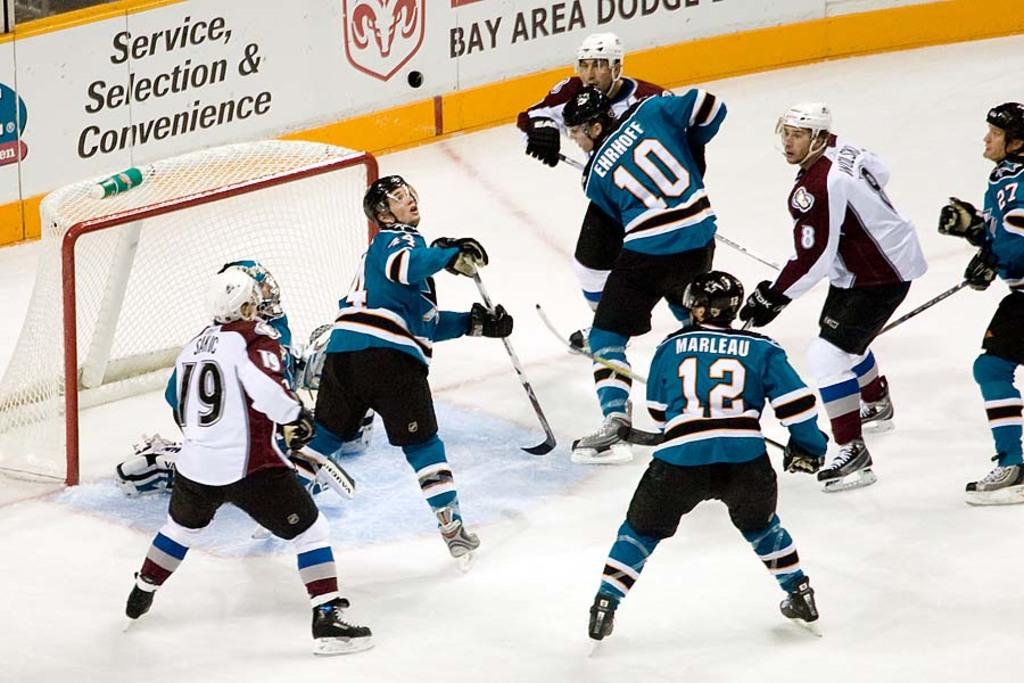What else is advertised besides just service and selection?
Ensure brevity in your answer.  Convenience. What is player 12's name?
Provide a short and direct response. Marleau. 